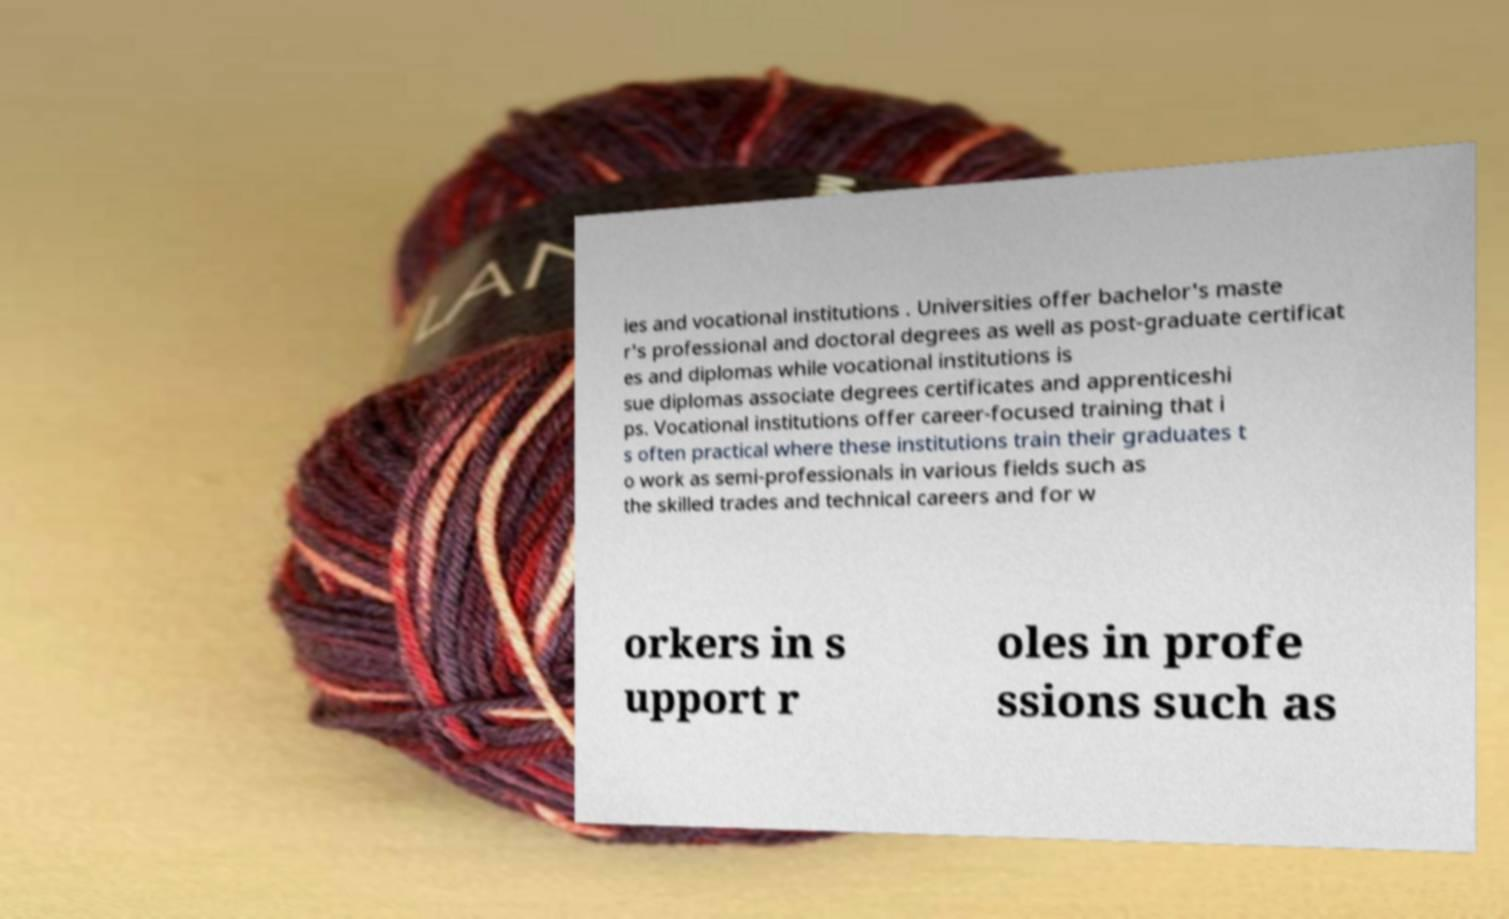Please read and relay the text visible in this image. What does it say? ies and vocational institutions . Universities offer bachelor's maste r's professional and doctoral degrees as well as post-graduate certificat es and diplomas while vocational institutions is sue diplomas associate degrees certificates and apprenticeshi ps. Vocational institutions offer career-focused training that i s often practical where these institutions train their graduates t o work as semi-professionals in various fields such as the skilled trades and technical careers and for w orkers in s upport r oles in profe ssions such as 